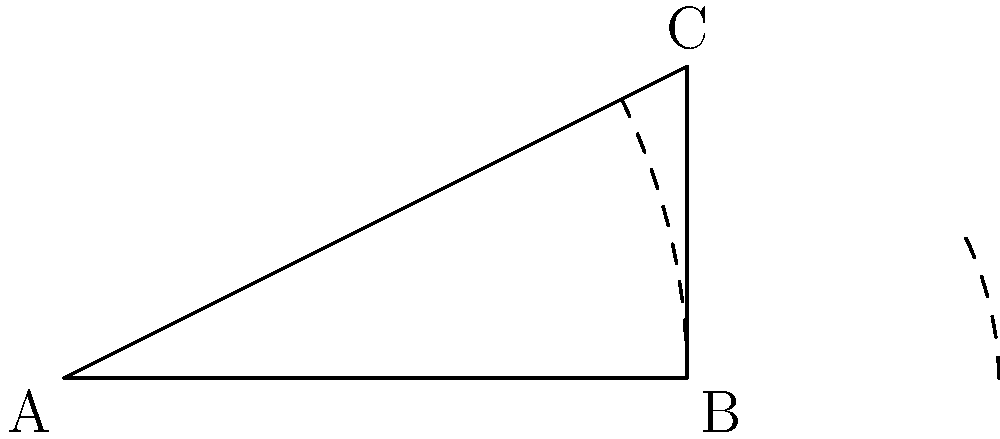A Renault Clio hatchback is making a turn on a test track. The car's wheelbase (distance between front and rear axles) is 10 meters, and the front wheels are turned at an angle of 26.57°. If the distance from the rear axle to the center of the turn is 5 meters, what is the turning radius (R) of the Renault Clio? Let's approach this step-by-step:

1) First, we need to recognize that this forms a right-angled triangle, where:
   - The hypotenuse is the turning radius (R)
   - One side is the wheelbase (10 m)
   - The other side is the distance from the rear axle to the center of the turn (5 m)

2) We can use the Pythagorean theorem to find R:

   $$R^2 = 10^2 + 5^2$$

3) Simplify:
   $$R^2 = 100 + 25 = 125$$

4) Take the square root of both sides:
   $$R = \sqrt{125}$$

5) Simplify the square root:
   $$R = 5\sqrt{5}$$

6) To get a decimal approximation:
   $$R \approx 11.18$$ meters

Therefore, the turning radius of the Renault Clio hatchback is $5\sqrt{5}$ meters or approximately 11.18 meters.
Answer: $5\sqrt{5}$ meters 